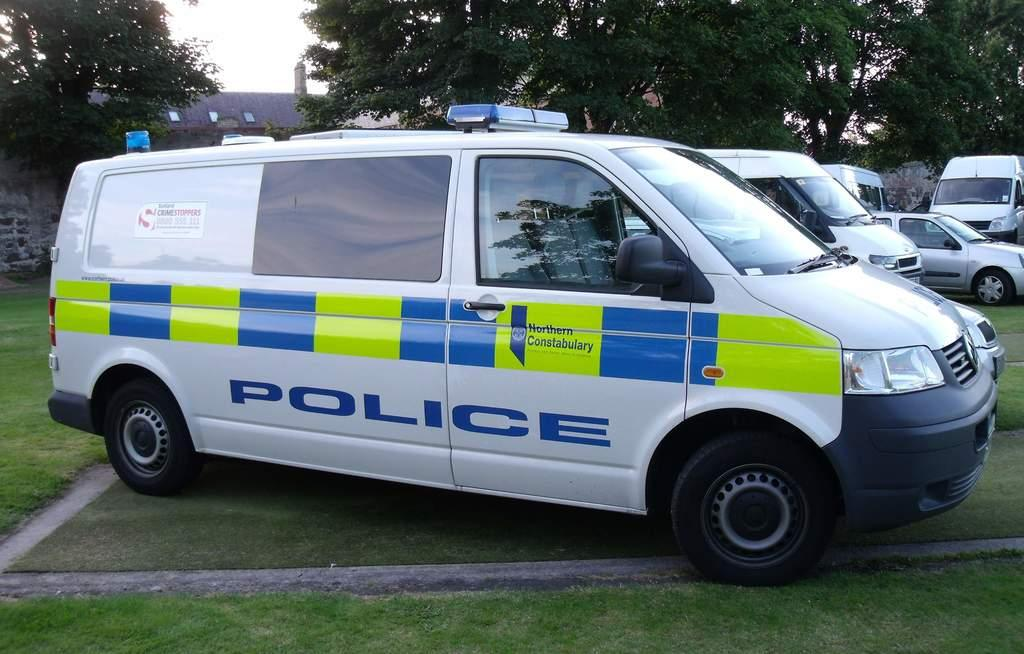<image>
Render a clear and concise summary of the photo. A police van from Northern Constabulary is yellow and blue. 